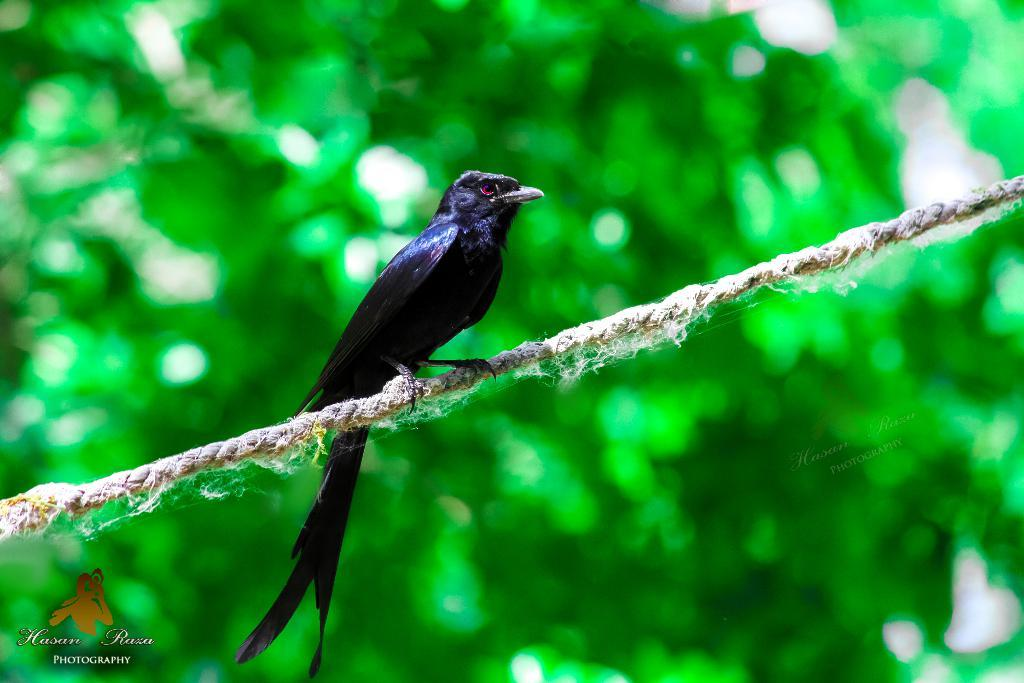What is present in the picture that can be used for tying or hanging objects? There is a rope in the picture. What type of animal can be seen in the picture? There is a black bird in the picture. What can be seen in the background of the picture, but not clearly? There are plants visible in the background, but they are not clearly visible. What is the price of the grain in the picture? There is no grain present in the image, so it is not possible to determine its price. 